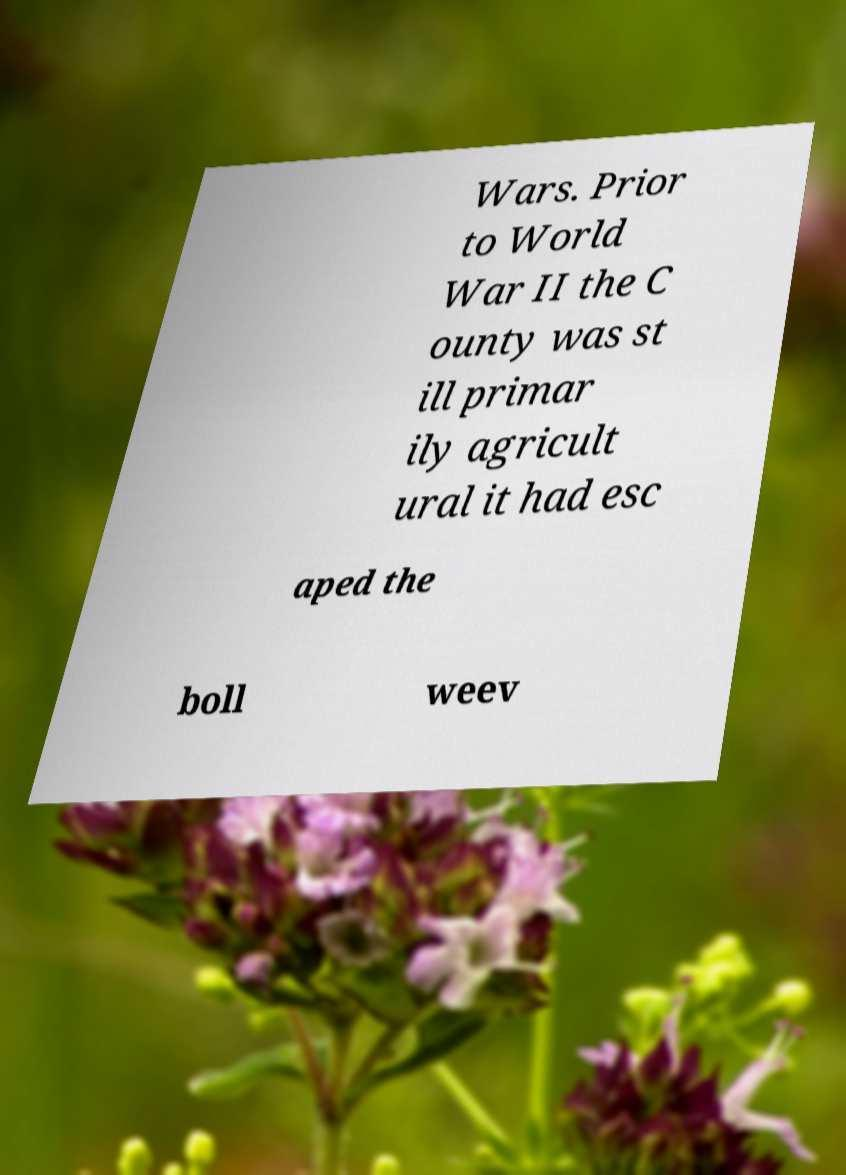For documentation purposes, I need the text within this image transcribed. Could you provide that? Wars. Prior to World War II the C ounty was st ill primar ily agricult ural it had esc aped the boll weev 